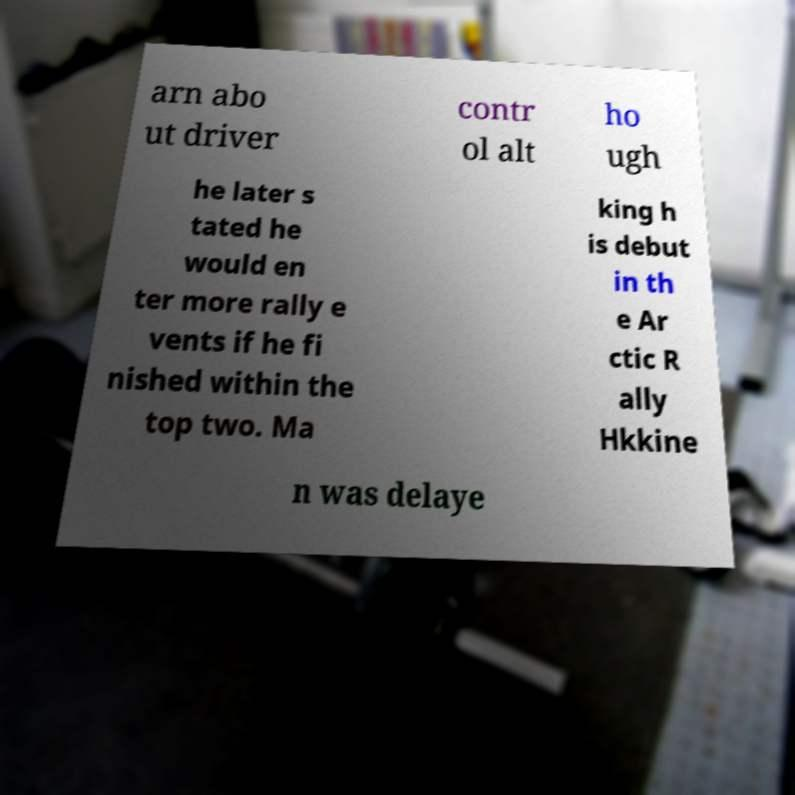Could you extract and type out the text from this image? arn abo ut driver contr ol alt ho ugh he later s tated he would en ter more rally e vents if he fi nished within the top two. Ma king h is debut in th e Ar ctic R ally Hkkine n was delaye 